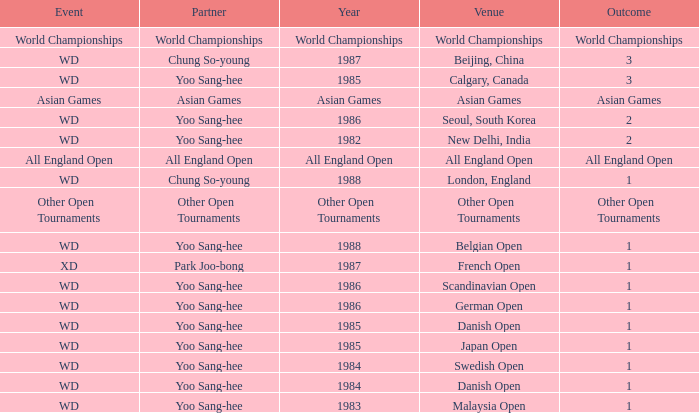Parse the table in full. {'header': ['Event', 'Partner', 'Year', 'Venue', 'Outcome'], 'rows': [['World Championships', 'World Championships', 'World Championships', 'World Championships', 'World Championships'], ['WD', 'Chung So-young', '1987', 'Beijing, China', '3'], ['WD', 'Yoo Sang-hee', '1985', 'Calgary, Canada', '3'], ['Asian Games', 'Asian Games', 'Asian Games', 'Asian Games', 'Asian Games'], ['WD', 'Yoo Sang-hee', '1986', 'Seoul, South Korea', '2'], ['WD', 'Yoo Sang-hee', '1982', 'New Delhi, India', '2'], ['All England Open', 'All England Open', 'All England Open', 'All England Open', 'All England Open'], ['WD', 'Chung So-young', '1988', 'London, England', '1'], ['Other Open Tournaments', 'Other Open Tournaments', 'Other Open Tournaments', 'Other Open Tournaments', 'Other Open Tournaments'], ['WD', 'Yoo Sang-hee', '1988', 'Belgian Open', '1'], ['XD', 'Park Joo-bong', '1987', 'French Open', '1'], ['WD', 'Yoo Sang-hee', '1986', 'Scandinavian Open', '1'], ['WD', 'Yoo Sang-hee', '1986', 'German Open', '1'], ['WD', 'Yoo Sang-hee', '1985', 'Danish Open', '1'], ['WD', 'Yoo Sang-hee', '1985', 'Japan Open', '1'], ['WD', 'Yoo Sang-hee', '1984', 'Swedish Open', '1'], ['WD', 'Yoo Sang-hee', '1984', 'Danish Open', '1'], ['WD', 'Yoo Sang-hee', '1983', 'Malaysia Open', '1']]} What is the Partner during the Asian Games Year? Asian Games. 